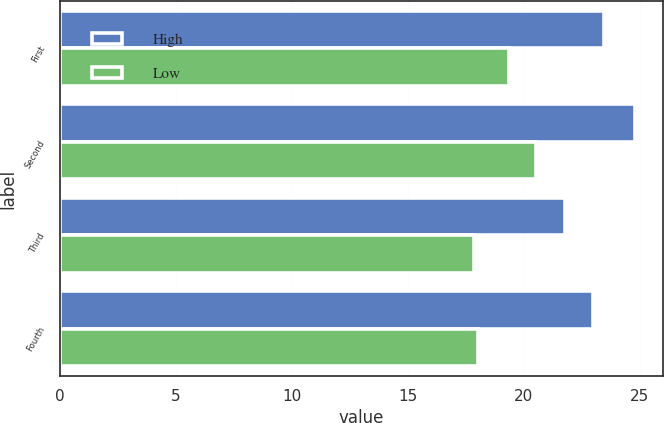<chart> <loc_0><loc_0><loc_500><loc_500><stacked_bar_chart><ecel><fcel>First<fcel>Second<fcel>Third<fcel>Fourth<nl><fcel>High<fcel>23.44<fcel>24.78<fcel>21.8<fcel>22.99<nl><fcel>Low<fcel>19.36<fcel>20.54<fcel>17.86<fcel>18.01<nl></chart> 